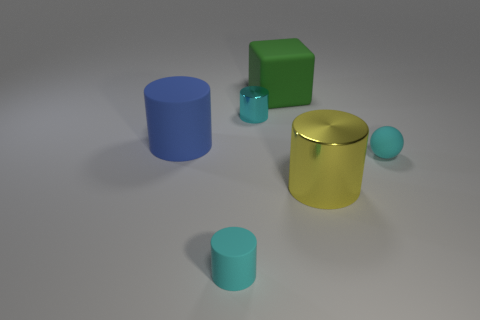There is a big rubber object on the left side of the tiny cyan matte cylinder; what is its color?
Make the answer very short. Blue. Is the number of yellow things on the right side of the big yellow thing greater than the number of tiny cyan metal objects?
Your response must be concise. No. Is the material of the large yellow cylinder the same as the ball?
Your response must be concise. No. How many other objects are the same shape as the blue matte thing?
Your answer should be very brief. 3. Are there any other things that are made of the same material as the small ball?
Give a very brief answer. Yes. What is the color of the matte thing on the left side of the small cyan cylinder in front of the tiny cyan matte object that is on the right side of the green matte block?
Your answer should be compact. Blue. There is a tiny cyan object that is in front of the big yellow thing; is it the same shape as the big blue matte object?
Provide a succinct answer. Yes. How many large purple cubes are there?
Offer a terse response. 0. What number of cyan things have the same size as the cyan rubber cylinder?
Make the answer very short. 2. What is the big green thing made of?
Keep it short and to the point. Rubber. 